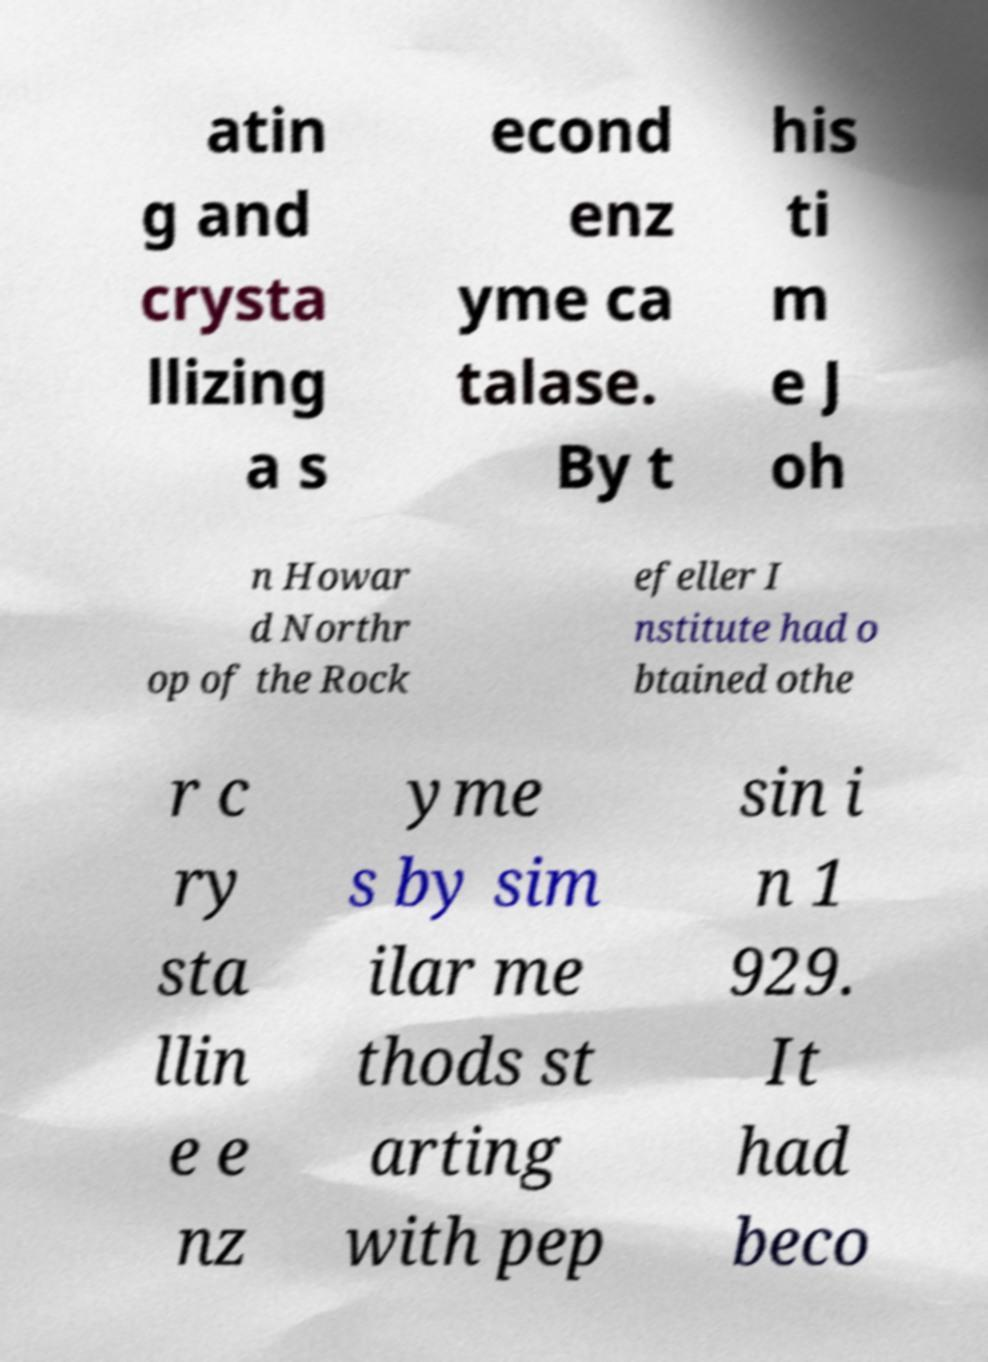What messages or text are displayed in this image? I need them in a readable, typed format. atin g and crysta llizing a s econd enz yme ca talase. By t his ti m e J oh n Howar d Northr op of the Rock efeller I nstitute had o btained othe r c ry sta llin e e nz yme s by sim ilar me thods st arting with pep sin i n 1 929. It had beco 